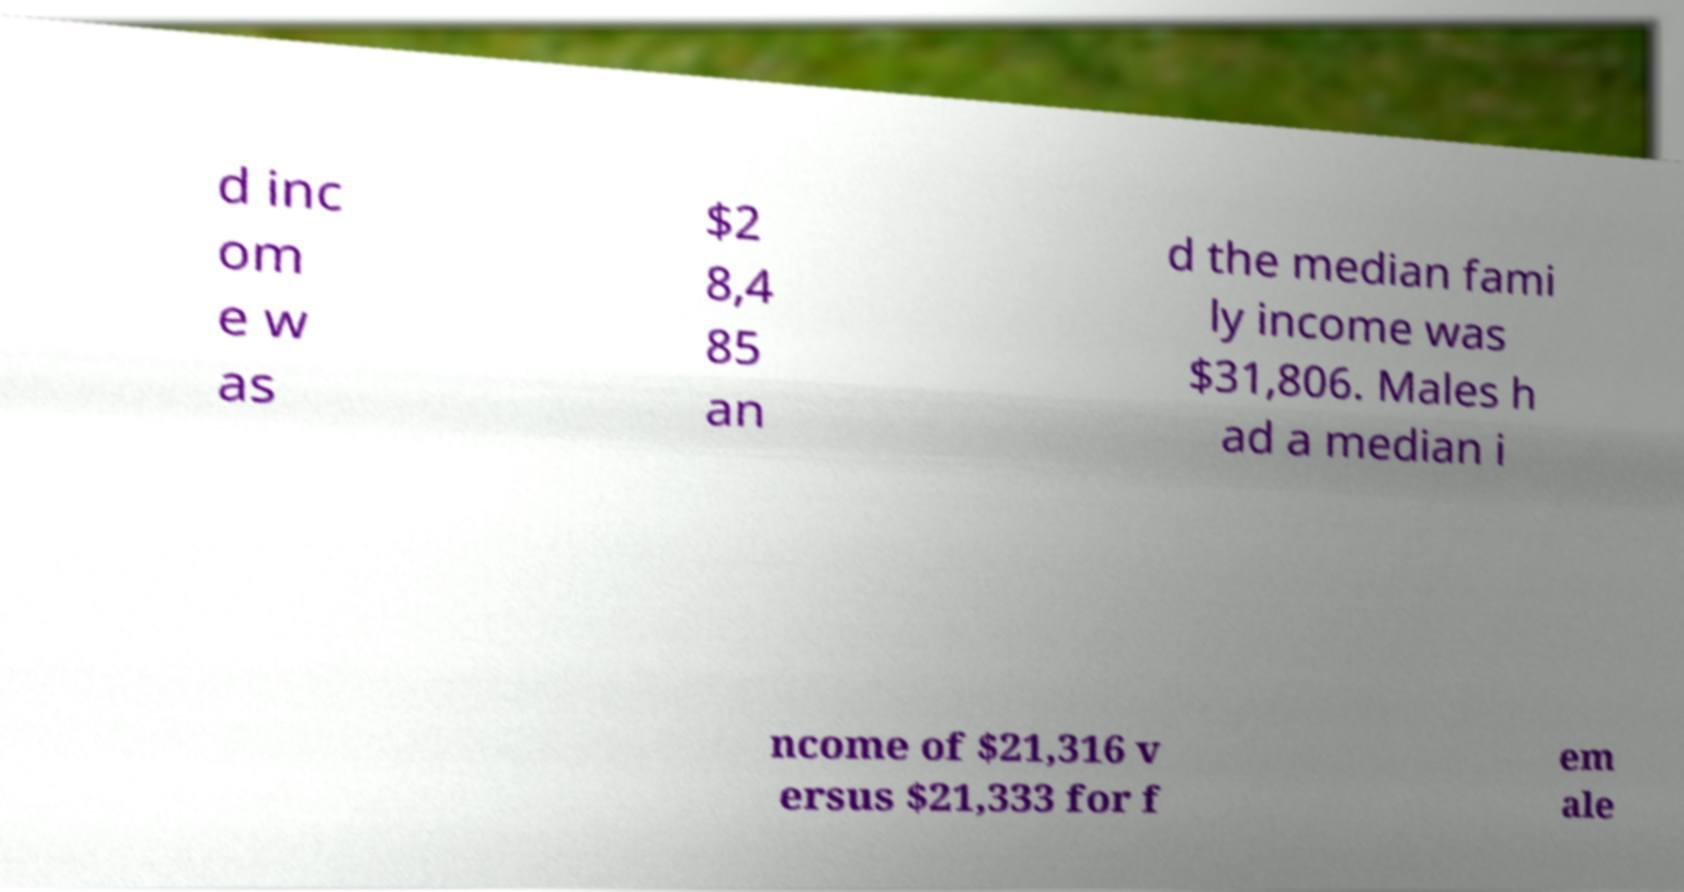Can you read and provide the text displayed in the image?This photo seems to have some interesting text. Can you extract and type it out for me? d inc om e w as $2 8,4 85 an d the median fami ly income was $31,806. Males h ad a median i ncome of $21,316 v ersus $21,333 for f em ale 